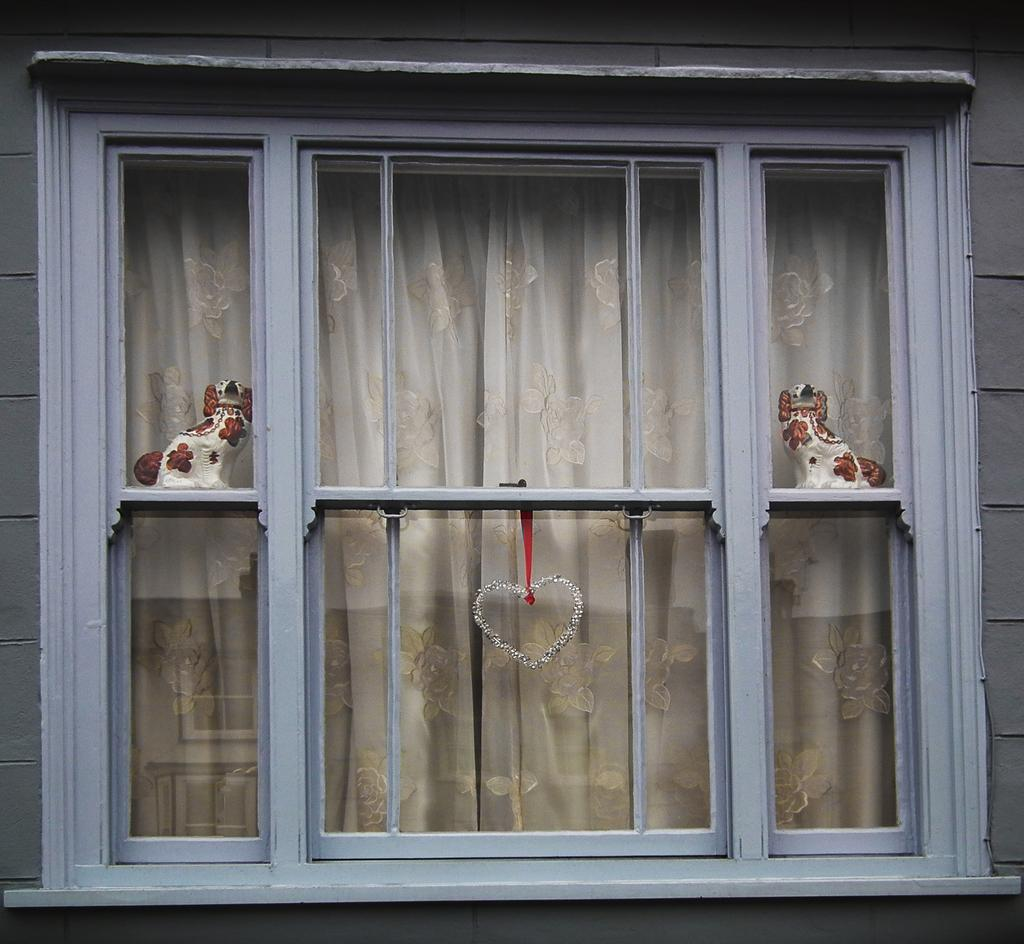What can be seen through the window in the image? A curtain is visible through the window in the image. Are there any objects on the window? Yes, there are two toys on the window. What is the background of the image? There is a wall in the image. What type of crime is being committed in the image? There is no crime being committed in the image; it only features a window with a curtain and two toys. How many jars are visible in the image? There are no jars present in the image. 